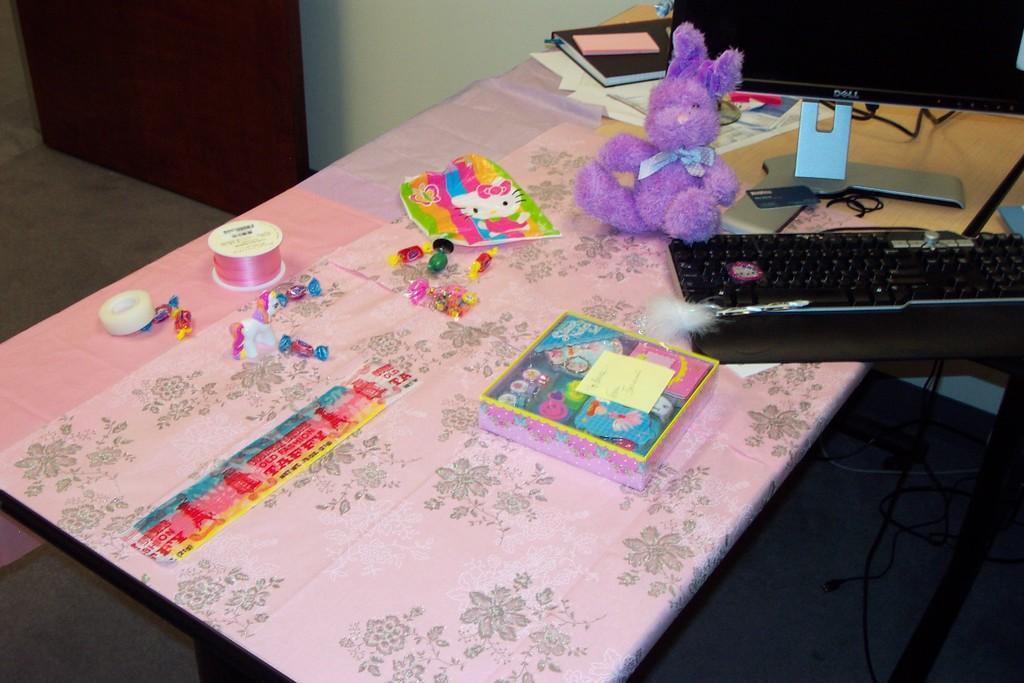Describe this image in one or two sentences. This picture shows few toys and a soft toy and a keyboard and a monitor and few papers and book on the table. 